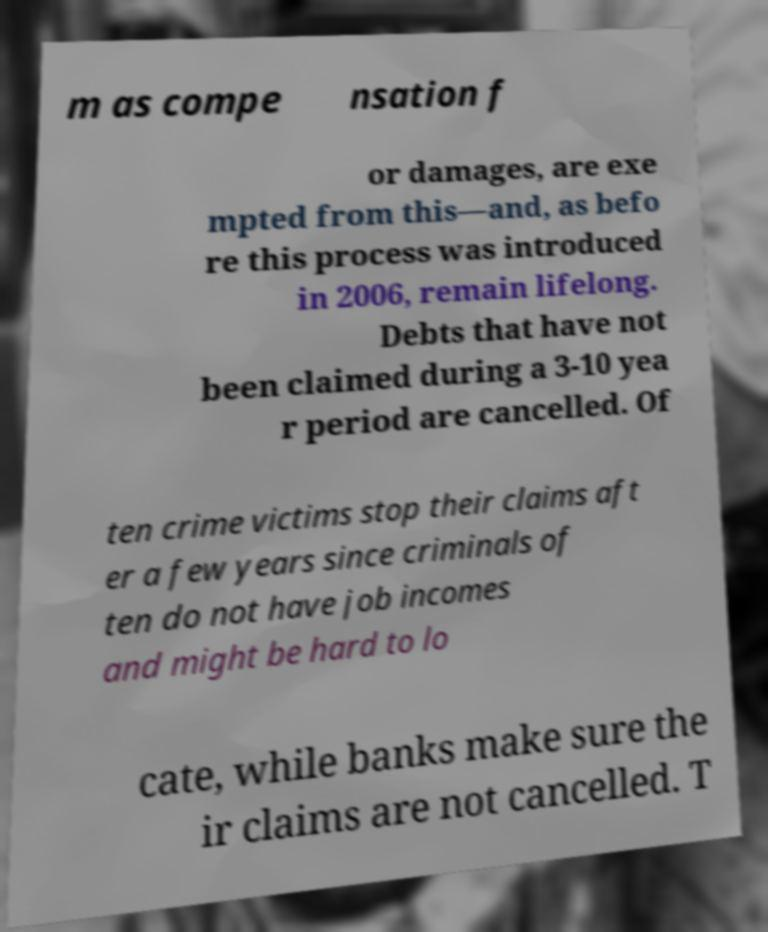What messages or text are displayed in this image? I need them in a readable, typed format. m as compe nsation f or damages, are exe mpted from this—and, as befo re this process was introduced in 2006, remain lifelong. Debts that have not been claimed during a 3-10 yea r period are cancelled. Of ten crime victims stop their claims aft er a few years since criminals of ten do not have job incomes and might be hard to lo cate, while banks make sure the ir claims are not cancelled. T 